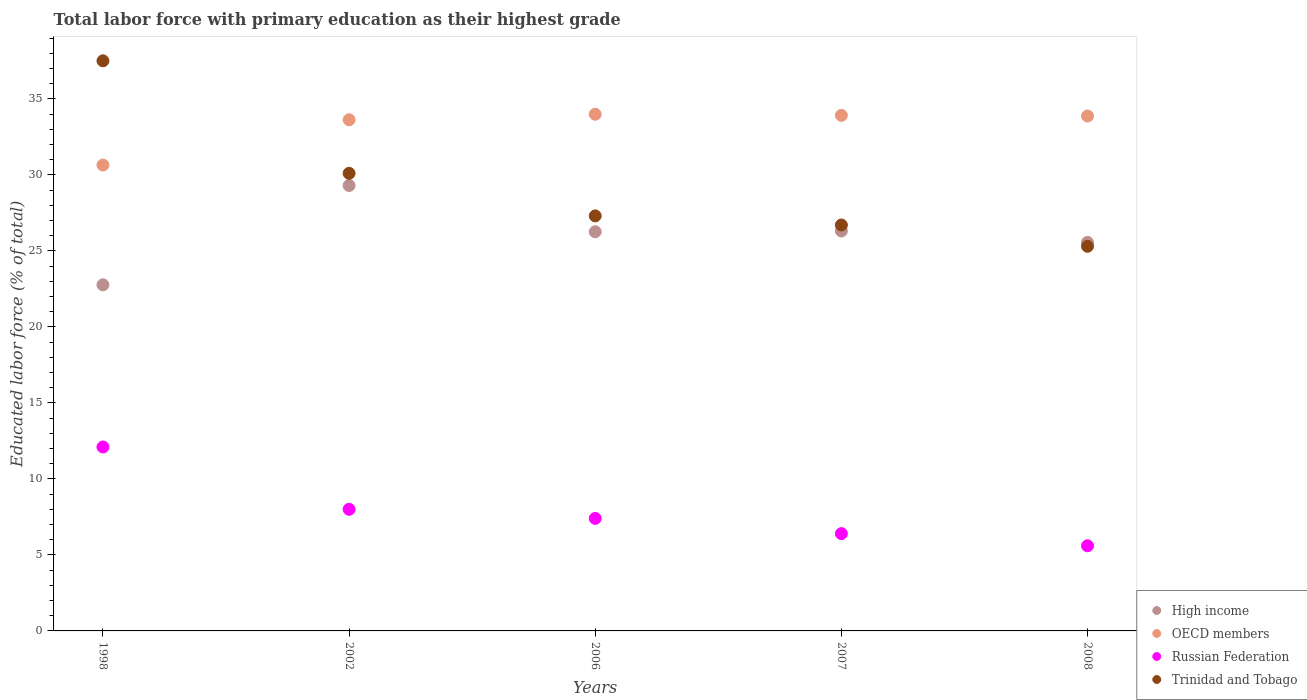How many different coloured dotlines are there?
Keep it short and to the point. 4. Is the number of dotlines equal to the number of legend labels?
Provide a short and direct response. Yes. What is the percentage of total labor force with primary education in Trinidad and Tobago in 2007?
Ensure brevity in your answer.  26.7. Across all years, what is the maximum percentage of total labor force with primary education in High income?
Keep it short and to the point. 29.3. Across all years, what is the minimum percentage of total labor force with primary education in Trinidad and Tobago?
Give a very brief answer. 25.3. In which year was the percentage of total labor force with primary education in Russian Federation minimum?
Offer a very short reply. 2008. What is the total percentage of total labor force with primary education in Trinidad and Tobago in the graph?
Keep it short and to the point. 146.9. What is the difference between the percentage of total labor force with primary education in Trinidad and Tobago in 1998 and that in 2007?
Provide a succinct answer. 10.8. What is the difference between the percentage of total labor force with primary education in Russian Federation in 2006 and the percentage of total labor force with primary education in Trinidad and Tobago in 2002?
Provide a short and direct response. -22.7. What is the average percentage of total labor force with primary education in Russian Federation per year?
Provide a short and direct response. 7.9. In the year 2006, what is the difference between the percentage of total labor force with primary education in OECD members and percentage of total labor force with primary education in High income?
Your answer should be very brief. 7.73. What is the ratio of the percentage of total labor force with primary education in Trinidad and Tobago in 1998 to that in 2006?
Your answer should be very brief. 1.37. What is the difference between the highest and the second highest percentage of total labor force with primary education in Trinidad and Tobago?
Ensure brevity in your answer.  7.4. What is the difference between the highest and the lowest percentage of total labor force with primary education in High income?
Provide a succinct answer. 6.53. Is the sum of the percentage of total labor force with primary education in Russian Federation in 2002 and 2007 greater than the maximum percentage of total labor force with primary education in High income across all years?
Keep it short and to the point. No. Is it the case that in every year, the sum of the percentage of total labor force with primary education in Trinidad and Tobago and percentage of total labor force with primary education in High income  is greater than the sum of percentage of total labor force with primary education in Russian Federation and percentage of total labor force with primary education in OECD members?
Offer a very short reply. No. Is it the case that in every year, the sum of the percentage of total labor force with primary education in Trinidad and Tobago and percentage of total labor force with primary education in OECD members  is greater than the percentage of total labor force with primary education in High income?
Offer a terse response. Yes. Is the percentage of total labor force with primary education in Trinidad and Tobago strictly greater than the percentage of total labor force with primary education in High income over the years?
Provide a short and direct response. No. Is the percentage of total labor force with primary education in OECD members strictly less than the percentage of total labor force with primary education in Russian Federation over the years?
Your answer should be very brief. No. How many years are there in the graph?
Ensure brevity in your answer.  5. Does the graph contain any zero values?
Provide a succinct answer. No. Does the graph contain grids?
Ensure brevity in your answer.  No. Where does the legend appear in the graph?
Make the answer very short. Bottom right. How many legend labels are there?
Your answer should be compact. 4. How are the legend labels stacked?
Provide a succinct answer. Vertical. What is the title of the graph?
Your answer should be very brief. Total labor force with primary education as their highest grade. What is the label or title of the Y-axis?
Offer a very short reply. Educated labor force (% of total). What is the Educated labor force (% of total) of High income in 1998?
Keep it short and to the point. 22.77. What is the Educated labor force (% of total) of OECD members in 1998?
Your answer should be very brief. 30.64. What is the Educated labor force (% of total) of Russian Federation in 1998?
Provide a short and direct response. 12.1. What is the Educated labor force (% of total) of Trinidad and Tobago in 1998?
Offer a very short reply. 37.5. What is the Educated labor force (% of total) in High income in 2002?
Offer a very short reply. 29.3. What is the Educated labor force (% of total) of OECD members in 2002?
Provide a short and direct response. 33.62. What is the Educated labor force (% of total) of Trinidad and Tobago in 2002?
Make the answer very short. 30.1. What is the Educated labor force (% of total) in High income in 2006?
Give a very brief answer. 26.26. What is the Educated labor force (% of total) in OECD members in 2006?
Your answer should be very brief. 33.99. What is the Educated labor force (% of total) of Russian Federation in 2006?
Offer a terse response. 7.4. What is the Educated labor force (% of total) of Trinidad and Tobago in 2006?
Offer a terse response. 27.3. What is the Educated labor force (% of total) in High income in 2007?
Keep it short and to the point. 26.31. What is the Educated labor force (% of total) of OECD members in 2007?
Make the answer very short. 33.91. What is the Educated labor force (% of total) in Russian Federation in 2007?
Make the answer very short. 6.4. What is the Educated labor force (% of total) of Trinidad and Tobago in 2007?
Provide a short and direct response. 26.7. What is the Educated labor force (% of total) in High income in 2008?
Offer a terse response. 25.56. What is the Educated labor force (% of total) in OECD members in 2008?
Offer a terse response. 33.87. What is the Educated labor force (% of total) of Russian Federation in 2008?
Your answer should be compact. 5.6. What is the Educated labor force (% of total) of Trinidad and Tobago in 2008?
Provide a short and direct response. 25.3. Across all years, what is the maximum Educated labor force (% of total) in High income?
Your answer should be compact. 29.3. Across all years, what is the maximum Educated labor force (% of total) in OECD members?
Give a very brief answer. 33.99. Across all years, what is the maximum Educated labor force (% of total) in Russian Federation?
Your response must be concise. 12.1. Across all years, what is the maximum Educated labor force (% of total) in Trinidad and Tobago?
Provide a short and direct response. 37.5. Across all years, what is the minimum Educated labor force (% of total) in High income?
Your answer should be very brief. 22.77. Across all years, what is the minimum Educated labor force (% of total) of OECD members?
Provide a succinct answer. 30.64. Across all years, what is the minimum Educated labor force (% of total) of Russian Federation?
Provide a short and direct response. 5.6. Across all years, what is the minimum Educated labor force (% of total) of Trinidad and Tobago?
Your response must be concise. 25.3. What is the total Educated labor force (% of total) in High income in the graph?
Ensure brevity in your answer.  130.19. What is the total Educated labor force (% of total) of OECD members in the graph?
Keep it short and to the point. 166.03. What is the total Educated labor force (% of total) in Russian Federation in the graph?
Give a very brief answer. 39.5. What is the total Educated labor force (% of total) of Trinidad and Tobago in the graph?
Offer a very short reply. 146.9. What is the difference between the Educated labor force (% of total) of High income in 1998 and that in 2002?
Your answer should be compact. -6.54. What is the difference between the Educated labor force (% of total) of OECD members in 1998 and that in 2002?
Your response must be concise. -2.98. What is the difference between the Educated labor force (% of total) of Russian Federation in 1998 and that in 2002?
Give a very brief answer. 4.1. What is the difference between the Educated labor force (% of total) in Trinidad and Tobago in 1998 and that in 2002?
Give a very brief answer. 7.4. What is the difference between the Educated labor force (% of total) of High income in 1998 and that in 2006?
Your answer should be compact. -3.49. What is the difference between the Educated labor force (% of total) of OECD members in 1998 and that in 2006?
Provide a short and direct response. -3.34. What is the difference between the Educated labor force (% of total) in Trinidad and Tobago in 1998 and that in 2006?
Your answer should be very brief. 10.2. What is the difference between the Educated labor force (% of total) of High income in 1998 and that in 2007?
Provide a short and direct response. -3.54. What is the difference between the Educated labor force (% of total) in OECD members in 1998 and that in 2007?
Provide a succinct answer. -3.27. What is the difference between the Educated labor force (% of total) of Trinidad and Tobago in 1998 and that in 2007?
Keep it short and to the point. 10.8. What is the difference between the Educated labor force (% of total) of High income in 1998 and that in 2008?
Offer a terse response. -2.79. What is the difference between the Educated labor force (% of total) in OECD members in 1998 and that in 2008?
Ensure brevity in your answer.  -3.22. What is the difference between the Educated labor force (% of total) in Russian Federation in 1998 and that in 2008?
Offer a terse response. 6.5. What is the difference between the Educated labor force (% of total) in Trinidad and Tobago in 1998 and that in 2008?
Give a very brief answer. 12.2. What is the difference between the Educated labor force (% of total) of High income in 2002 and that in 2006?
Offer a terse response. 3.04. What is the difference between the Educated labor force (% of total) in OECD members in 2002 and that in 2006?
Your response must be concise. -0.36. What is the difference between the Educated labor force (% of total) of Russian Federation in 2002 and that in 2006?
Keep it short and to the point. 0.6. What is the difference between the Educated labor force (% of total) in Trinidad and Tobago in 2002 and that in 2006?
Your response must be concise. 2.8. What is the difference between the Educated labor force (% of total) in High income in 2002 and that in 2007?
Offer a terse response. 2.99. What is the difference between the Educated labor force (% of total) of OECD members in 2002 and that in 2007?
Offer a terse response. -0.29. What is the difference between the Educated labor force (% of total) in High income in 2002 and that in 2008?
Give a very brief answer. 3.74. What is the difference between the Educated labor force (% of total) in OECD members in 2002 and that in 2008?
Your answer should be very brief. -0.24. What is the difference between the Educated labor force (% of total) in High income in 2006 and that in 2007?
Ensure brevity in your answer.  -0.05. What is the difference between the Educated labor force (% of total) of OECD members in 2006 and that in 2007?
Give a very brief answer. 0.07. What is the difference between the Educated labor force (% of total) of Russian Federation in 2006 and that in 2007?
Ensure brevity in your answer.  1. What is the difference between the Educated labor force (% of total) in High income in 2006 and that in 2008?
Provide a succinct answer. 0.7. What is the difference between the Educated labor force (% of total) in OECD members in 2006 and that in 2008?
Your response must be concise. 0.12. What is the difference between the Educated labor force (% of total) in Russian Federation in 2006 and that in 2008?
Provide a short and direct response. 1.8. What is the difference between the Educated labor force (% of total) of Trinidad and Tobago in 2006 and that in 2008?
Offer a very short reply. 2. What is the difference between the Educated labor force (% of total) in High income in 2007 and that in 2008?
Provide a succinct answer. 0.75. What is the difference between the Educated labor force (% of total) in OECD members in 2007 and that in 2008?
Offer a terse response. 0.05. What is the difference between the Educated labor force (% of total) of Russian Federation in 2007 and that in 2008?
Your response must be concise. 0.8. What is the difference between the Educated labor force (% of total) of High income in 1998 and the Educated labor force (% of total) of OECD members in 2002?
Ensure brevity in your answer.  -10.86. What is the difference between the Educated labor force (% of total) in High income in 1998 and the Educated labor force (% of total) in Russian Federation in 2002?
Offer a terse response. 14.77. What is the difference between the Educated labor force (% of total) of High income in 1998 and the Educated labor force (% of total) of Trinidad and Tobago in 2002?
Your response must be concise. -7.33. What is the difference between the Educated labor force (% of total) in OECD members in 1998 and the Educated labor force (% of total) in Russian Federation in 2002?
Your answer should be compact. 22.64. What is the difference between the Educated labor force (% of total) of OECD members in 1998 and the Educated labor force (% of total) of Trinidad and Tobago in 2002?
Provide a short and direct response. 0.54. What is the difference between the Educated labor force (% of total) in Russian Federation in 1998 and the Educated labor force (% of total) in Trinidad and Tobago in 2002?
Give a very brief answer. -18. What is the difference between the Educated labor force (% of total) of High income in 1998 and the Educated labor force (% of total) of OECD members in 2006?
Make the answer very short. -11.22. What is the difference between the Educated labor force (% of total) of High income in 1998 and the Educated labor force (% of total) of Russian Federation in 2006?
Your answer should be very brief. 15.37. What is the difference between the Educated labor force (% of total) in High income in 1998 and the Educated labor force (% of total) in Trinidad and Tobago in 2006?
Your answer should be very brief. -4.53. What is the difference between the Educated labor force (% of total) of OECD members in 1998 and the Educated labor force (% of total) of Russian Federation in 2006?
Provide a succinct answer. 23.24. What is the difference between the Educated labor force (% of total) in OECD members in 1998 and the Educated labor force (% of total) in Trinidad and Tobago in 2006?
Provide a short and direct response. 3.34. What is the difference between the Educated labor force (% of total) in Russian Federation in 1998 and the Educated labor force (% of total) in Trinidad and Tobago in 2006?
Offer a terse response. -15.2. What is the difference between the Educated labor force (% of total) in High income in 1998 and the Educated labor force (% of total) in OECD members in 2007?
Your answer should be very brief. -11.15. What is the difference between the Educated labor force (% of total) in High income in 1998 and the Educated labor force (% of total) in Russian Federation in 2007?
Make the answer very short. 16.37. What is the difference between the Educated labor force (% of total) of High income in 1998 and the Educated labor force (% of total) of Trinidad and Tobago in 2007?
Your answer should be very brief. -3.93. What is the difference between the Educated labor force (% of total) in OECD members in 1998 and the Educated labor force (% of total) in Russian Federation in 2007?
Make the answer very short. 24.24. What is the difference between the Educated labor force (% of total) in OECD members in 1998 and the Educated labor force (% of total) in Trinidad and Tobago in 2007?
Ensure brevity in your answer.  3.94. What is the difference between the Educated labor force (% of total) in Russian Federation in 1998 and the Educated labor force (% of total) in Trinidad and Tobago in 2007?
Keep it short and to the point. -14.6. What is the difference between the Educated labor force (% of total) in High income in 1998 and the Educated labor force (% of total) in OECD members in 2008?
Provide a short and direct response. -11.1. What is the difference between the Educated labor force (% of total) of High income in 1998 and the Educated labor force (% of total) of Russian Federation in 2008?
Provide a succinct answer. 17.17. What is the difference between the Educated labor force (% of total) of High income in 1998 and the Educated labor force (% of total) of Trinidad and Tobago in 2008?
Keep it short and to the point. -2.53. What is the difference between the Educated labor force (% of total) of OECD members in 1998 and the Educated labor force (% of total) of Russian Federation in 2008?
Keep it short and to the point. 25.04. What is the difference between the Educated labor force (% of total) of OECD members in 1998 and the Educated labor force (% of total) of Trinidad and Tobago in 2008?
Make the answer very short. 5.34. What is the difference between the Educated labor force (% of total) of Russian Federation in 1998 and the Educated labor force (% of total) of Trinidad and Tobago in 2008?
Your response must be concise. -13.2. What is the difference between the Educated labor force (% of total) in High income in 2002 and the Educated labor force (% of total) in OECD members in 2006?
Provide a short and direct response. -4.69. What is the difference between the Educated labor force (% of total) of High income in 2002 and the Educated labor force (% of total) of Russian Federation in 2006?
Your answer should be compact. 21.9. What is the difference between the Educated labor force (% of total) of High income in 2002 and the Educated labor force (% of total) of Trinidad and Tobago in 2006?
Keep it short and to the point. 2. What is the difference between the Educated labor force (% of total) of OECD members in 2002 and the Educated labor force (% of total) of Russian Federation in 2006?
Provide a short and direct response. 26.22. What is the difference between the Educated labor force (% of total) of OECD members in 2002 and the Educated labor force (% of total) of Trinidad and Tobago in 2006?
Provide a short and direct response. 6.32. What is the difference between the Educated labor force (% of total) in Russian Federation in 2002 and the Educated labor force (% of total) in Trinidad and Tobago in 2006?
Provide a short and direct response. -19.3. What is the difference between the Educated labor force (% of total) of High income in 2002 and the Educated labor force (% of total) of OECD members in 2007?
Keep it short and to the point. -4.61. What is the difference between the Educated labor force (% of total) of High income in 2002 and the Educated labor force (% of total) of Russian Federation in 2007?
Provide a short and direct response. 22.9. What is the difference between the Educated labor force (% of total) in High income in 2002 and the Educated labor force (% of total) in Trinidad and Tobago in 2007?
Keep it short and to the point. 2.6. What is the difference between the Educated labor force (% of total) in OECD members in 2002 and the Educated labor force (% of total) in Russian Federation in 2007?
Keep it short and to the point. 27.22. What is the difference between the Educated labor force (% of total) of OECD members in 2002 and the Educated labor force (% of total) of Trinidad and Tobago in 2007?
Ensure brevity in your answer.  6.92. What is the difference between the Educated labor force (% of total) in Russian Federation in 2002 and the Educated labor force (% of total) in Trinidad and Tobago in 2007?
Offer a very short reply. -18.7. What is the difference between the Educated labor force (% of total) in High income in 2002 and the Educated labor force (% of total) in OECD members in 2008?
Keep it short and to the point. -4.57. What is the difference between the Educated labor force (% of total) in High income in 2002 and the Educated labor force (% of total) in Russian Federation in 2008?
Your response must be concise. 23.7. What is the difference between the Educated labor force (% of total) of High income in 2002 and the Educated labor force (% of total) of Trinidad and Tobago in 2008?
Your answer should be compact. 4. What is the difference between the Educated labor force (% of total) in OECD members in 2002 and the Educated labor force (% of total) in Russian Federation in 2008?
Your answer should be compact. 28.02. What is the difference between the Educated labor force (% of total) of OECD members in 2002 and the Educated labor force (% of total) of Trinidad and Tobago in 2008?
Provide a short and direct response. 8.32. What is the difference between the Educated labor force (% of total) of Russian Federation in 2002 and the Educated labor force (% of total) of Trinidad and Tobago in 2008?
Ensure brevity in your answer.  -17.3. What is the difference between the Educated labor force (% of total) in High income in 2006 and the Educated labor force (% of total) in OECD members in 2007?
Your answer should be compact. -7.66. What is the difference between the Educated labor force (% of total) of High income in 2006 and the Educated labor force (% of total) of Russian Federation in 2007?
Provide a short and direct response. 19.86. What is the difference between the Educated labor force (% of total) in High income in 2006 and the Educated labor force (% of total) in Trinidad and Tobago in 2007?
Your answer should be compact. -0.44. What is the difference between the Educated labor force (% of total) of OECD members in 2006 and the Educated labor force (% of total) of Russian Federation in 2007?
Provide a short and direct response. 27.59. What is the difference between the Educated labor force (% of total) of OECD members in 2006 and the Educated labor force (% of total) of Trinidad and Tobago in 2007?
Give a very brief answer. 7.29. What is the difference between the Educated labor force (% of total) of Russian Federation in 2006 and the Educated labor force (% of total) of Trinidad and Tobago in 2007?
Offer a very short reply. -19.3. What is the difference between the Educated labor force (% of total) of High income in 2006 and the Educated labor force (% of total) of OECD members in 2008?
Your answer should be very brief. -7.61. What is the difference between the Educated labor force (% of total) of High income in 2006 and the Educated labor force (% of total) of Russian Federation in 2008?
Keep it short and to the point. 20.66. What is the difference between the Educated labor force (% of total) of High income in 2006 and the Educated labor force (% of total) of Trinidad and Tobago in 2008?
Provide a short and direct response. 0.96. What is the difference between the Educated labor force (% of total) in OECD members in 2006 and the Educated labor force (% of total) in Russian Federation in 2008?
Ensure brevity in your answer.  28.39. What is the difference between the Educated labor force (% of total) in OECD members in 2006 and the Educated labor force (% of total) in Trinidad and Tobago in 2008?
Your answer should be very brief. 8.69. What is the difference between the Educated labor force (% of total) of Russian Federation in 2006 and the Educated labor force (% of total) of Trinidad and Tobago in 2008?
Your answer should be very brief. -17.9. What is the difference between the Educated labor force (% of total) in High income in 2007 and the Educated labor force (% of total) in OECD members in 2008?
Give a very brief answer. -7.56. What is the difference between the Educated labor force (% of total) of High income in 2007 and the Educated labor force (% of total) of Russian Federation in 2008?
Provide a short and direct response. 20.71. What is the difference between the Educated labor force (% of total) of High income in 2007 and the Educated labor force (% of total) of Trinidad and Tobago in 2008?
Provide a succinct answer. 1.01. What is the difference between the Educated labor force (% of total) of OECD members in 2007 and the Educated labor force (% of total) of Russian Federation in 2008?
Your answer should be very brief. 28.31. What is the difference between the Educated labor force (% of total) in OECD members in 2007 and the Educated labor force (% of total) in Trinidad and Tobago in 2008?
Your answer should be very brief. 8.61. What is the difference between the Educated labor force (% of total) of Russian Federation in 2007 and the Educated labor force (% of total) of Trinidad and Tobago in 2008?
Keep it short and to the point. -18.9. What is the average Educated labor force (% of total) in High income per year?
Your answer should be very brief. 26.04. What is the average Educated labor force (% of total) in OECD members per year?
Provide a short and direct response. 33.21. What is the average Educated labor force (% of total) of Trinidad and Tobago per year?
Make the answer very short. 29.38. In the year 1998, what is the difference between the Educated labor force (% of total) in High income and Educated labor force (% of total) in OECD members?
Your answer should be very brief. -7.88. In the year 1998, what is the difference between the Educated labor force (% of total) in High income and Educated labor force (% of total) in Russian Federation?
Give a very brief answer. 10.67. In the year 1998, what is the difference between the Educated labor force (% of total) of High income and Educated labor force (% of total) of Trinidad and Tobago?
Ensure brevity in your answer.  -14.73. In the year 1998, what is the difference between the Educated labor force (% of total) in OECD members and Educated labor force (% of total) in Russian Federation?
Provide a succinct answer. 18.54. In the year 1998, what is the difference between the Educated labor force (% of total) of OECD members and Educated labor force (% of total) of Trinidad and Tobago?
Provide a succinct answer. -6.86. In the year 1998, what is the difference between the Educated labor force (% of total) in Russian Federation and Educated labor force (% of total) in Trinidad and Tobago?
Provide a short and direct response. -25.4. In the year 2002, what is the difference between the Educated labor force (% of total) in High income and Educated labor force (% of total) in OECD members?
Provide a succinct answer. -4.32. In the year 2002, what is the difference between the Educated labor force (% of total) of High income and Educated labor force (% of total) of Russian Federation?
Offer a very short reply. 21.3. In the year 2002, what is the difference between the Educated labor force (% of total) of High income and Educated labor force (% of total) of Trinidad and Tobago?
Make the answer very short. -0.8. In the year 2002, what is the difference between the Educated labor force (% of total) of OECD members and Educated labor force (% of total) of Russian Federation?
Your answer should be compact. 25.62. In the year 2002, what is the difference between the Educated labor force (% of total) in OECD members and Educated labor force (% of total) in Trinidad and Tobago?
Offer a very short reply. 3.52. In the year 2002, what is the difference between the Educated labor force (% of total) in Russian Federation and Educated labor force (% of total) in Trinidad and Tobago?
Make the answer very short. -22.1. In the year 2006, what is the difference between the Educated labor force (% of total) in High income and Educated labor force (% of total) in OECD members?
Your answer should be very brief. -7.73. In the year 2006, what is the difference between the Educated labor force (% of total) in High income and Educated labor force (% of total) in Russian Federation?
Provide a short and direct response. 18.86. In the year 2006, what is the difference between the Educated labor force (% of total) in High income and Educated labor force (% of total) in Trinidad and Tobago?
Make the answer very short. -1.04. In the year 2006, what is the difference between the Educated labor force (% of total) of OECD members and Educated labor force (% of total) of Russian Federation?
Make the answer very short. 26.59. In the year 2006, what is the difference between the Educated labor force (% of total) in OECD members and Educated labor force (% of total) in Trinidad and Tobago?
Offer a very short reply. 6.69. In the year 2006, what is the difference between the Educated labor force (% of total) of Russian Federation and Educated labor force (% of total) of Trinidad and Tobago?
Offer a terse response. -19.9. In the year 2007, what is the difference between the Educated labor force (% of total) in High income and Educated labor force (% of total) in OECD members?
Keep it short and to the point. -7.61. In the year 2007, what is the difference between the Educated labor force (% of total) of High income and Educated labor force (% of total) of Russian Federation?
Give a very brief answer. 19.91. In the year 2007, what is the difference between the Educated labor force (% of total) in High income and Educated labor force (% of total) in Trinidad and Tobago?
Keep it short and to the point. -0.39. In the year 2007, what is the difference between the Educated labor force (% of total) in OECD members and Educated labor force (% of total) in Russian Federation?
Give a very brief answer. 27.51. In the year 2007, what is the difference between the Educated labor force (% of total) in OECD members and Educated labor force (% of total) in Trinidad and Tobago?
Ensure brevity in your answer.  7.21. In the year 2007, what is the difference between the Educated labor force (% of total) of Russian Federation and Educated labor force (% of total) of Trinidad and Tobago?
Give a very brief answer. -20.3. In the year 2008, what is the difference between the Educated labor force (% of total) of High income and Educated labor force (% of total) of OECD members?
Give a very brief answer. -8.31. In the year 2008, what is the difference between the Educated labor force (% of total) of High income and Educated labor force (% of total) of Russian Federation?
Your response must be concise. 19.96. In the year 2008, what is the difference between the Educated labor force (% of total) in High income and Educated labor force (% of total) in Trinidad and Tobago?
Keep it short and to the point. 0.26. In the year 2008, what is the difference between the Educated labor force (% of total) of OECD members and Educated labor force (% of total) of Russian Federation?
Provide a short and direct response. 28.27. In the year 2008, what is the difference between the Educated labor force (% of total) of OECD members and Educated labor force (% of total) of Trinidad and Tobago?
Your answer should be compact. 8.57. In the year 2008, what is the difference between the Educated labor force (% of total) in Russian Federation and Educated labor force (% of total) in Trinidad and Tobago?
Make the answer very short. -19.7. What is the ratio of the Educated labor force (% of total) in High income in 1998 to that in 2002?
Give a very brief answer. 0.78. What is the ratio of the Educated labor force (% of total) of OECD members in 1998 to that in 2002?
Offer a very short reply. 0.91. What is the ratio of the Educated labor force (% of total) in Russian Federation in 1998 to that in 2002?
Offer a terse response. 1.51. What is the ratio of the Educated labor force (% of total) in Trinidad and Tobago in 1998 to that in 2002?
Keep it short and to the point. 1.25. What is the ratio of the Educated labor force (% of total) of High income in 1998 to that in 2006?
Provide a short and direct response. 0.87. What is the ratio of the Educated labor force (% of total) of OECD members in 1998 to that in 2006?
Offer a very short reply. 0.9. What is the ratio of the Educated labor force (% of total) of Russian Federation in 1998 to that in 2006?
Offer a very short reply. 1.64. What is the ratio of the Educated labor force (% of total) in Trinidad and Tobago in 1998 to that in 2006?
Your answer should be very brief. 1.37. What is the ratio of the Educated labor force (% of total) in High income in 1998 to that in 2007?
Make the answer very short. 0.87. What is the ratio of the Educated labor force (% of total) of OECD members in 1998 to that in 2007?
Your response must be concise. 0.9. What is the ratio of the Educated labor force (% of total) in Russian Federation in 1998 to that in 2007?
Keep it short and to the point. 1.89. What is the ratio of the Educated labor force (% of total) in Trinidad and Tobago in 1998 to that in 2007?
Ensure brevity in your answer.  1.4. What is the ratio of the Educated labor force (% of total) of High income in 1998 to that in 2008?
Ensure brevity in your answer.  0.89. What is the ratio of the Educated labor force (% of total) in OECD members in 1998 to that in 2008?
Keep it short and to the point. 0.9. What is the ratio of the Educated labor force (% of total) of Russian Federation in 1998 to that in 2008?
Your answer should be very brief. 2.16. What is the ratio of the Educated labor force (% of total) in Trinidad and Tobago in 1998 to that in 2008?
Provide a short and direct response. 1.48. What is the ratio of the Educated labor force (% of total) in High income in 2002 to that in 2006?
Your answer should be compact. 1.12. What is the ratio of the Educated labor force (% of total) in OECD members in 2002 to that in 2006?
Give a very brief answer. 0.99. What is the ratio of the Educated labor force (% of total) of Russian Federation in 2002 to that in 2006?
Provide a succinct answer. 1.08. What is the ratio of the Educated labor force (% of total) of Trinidad and Tobago in 2002 to that in 2006?
Provide a short and direct response. 1.1. What is the ratio of the Educated labor force (% of total) in High income in 2002 to that in 2007?
Offer a terse response. 1.11. What is the ratio of the Educated labor force (% of total) of Trinidad and Tobago in 2002 to that in 2007?
Your answer should be compact. 1.13. What is the ratio of the Educated labor force (% of total) in High income in 2002 to that in 2008?
Offer a very short reply. 1.15. What is the ratio of the Educated labor force (% of total) of OECD members in 2002 to that in 2008?
Offer a terse response. 0.99. What is the ratio of the Educated labor force (% of total) in Russian Federation in 2002 to that in 2008?
Your answer should be compact. 1.43. What is the ratio of the Educated labor force (% of total) of Trinidad and Tobago in 2002 to that in 2008?
Your answer should be compact. 1.19. What is the ratio of the Educated labor force (% of total) in High income in 2006 to that in 2007?
Ensure brevity in your answer.  1. What is the ratio of the Educated labor force (% of total) of OECD members in 2006 to that in 2007?
Your response must be concise. 1. What is the ratio of the Educated labor force (% of total) of Russian Federation in 2006 to that in 2007?
Provide a succinct answer. 1.16. What is the ratio of the Educated labor force (% of total) in Trinidad and Tobago in 2006 to that in 2007?
Ensure brevity in your answer.  1.02. What is the ratio of the Educated labor force (% of total) of High income in 2006 to that in 2008?
Your answer should be compact. 1.03. What is the ratio of the Educated labor force (% of total) of Russian Federation in 2006 to that in 2008?
Your response must be concise. 1.32. What is the ratio of the Educated labor force (% of total) in Trinidad and Tobago in 2006 to that in 2008?
Provide a short and direct response. 1.08. What is the ratio of the Educated labor force (% of total) in High income in 2007 to that in 2008?
Your answer should be compact. 1.03. What is the ratio of the Educated labor force (% of total) in OECD members in 2007 to that in 2008?
Keep it short and to the point. 1. What is the ratio of the Educated labor force (% of total) in Russian Federation in 2007 to that in 2008?
Give a very brief answer. 1.14. What is the ratio of the Educated labor force (% of total) of Trinidad and Tobago in 2007 to that in 2008?
Your answer should be very brief. 1.06. What is the difference between the highest and the second highest Educated labor force (% of total) of High income?
Offer a very short reply. 2.99. What is the difference between the highest and the second highest Educated labor force (% of total) of OECD members?
Offer a very short reply. 0.07. What is the difference between the highest and the second highest Educated labor force (% of total) of Trinidad and Tobago?
Ensure brevity in your answer.  7.4. What is the difference between the highest and the lowest Educated labor force (% of total) in High income?
Provide a succinct answer. 6.54. What is the difference between the highest and the lowest Educated labor force (% of total) in OECD members?
Give a very brief answer. 3.34. What is the difference between the highest and the lowest Educated labor force (% of total) in Russian Federation?
Your answer should be compact. 6.5. 